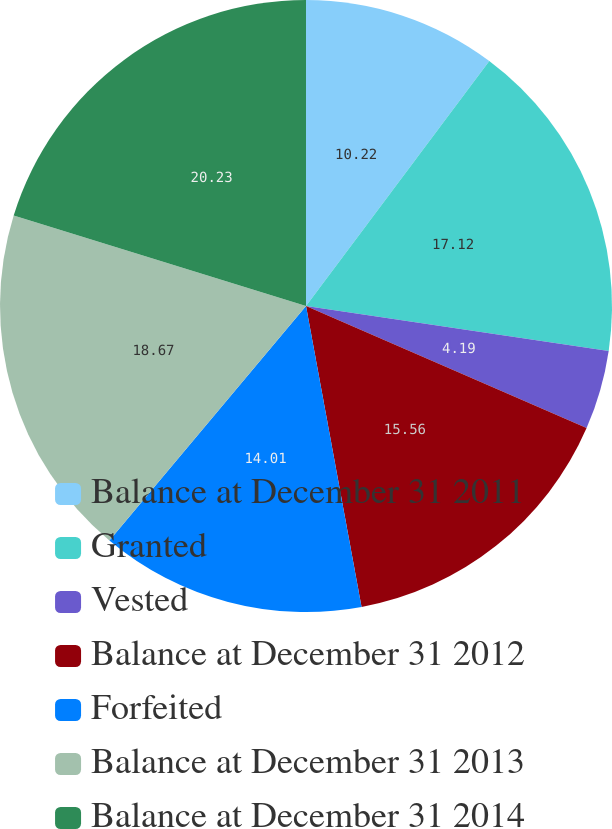<chart> <loc_0><loc_0><loc_500><loc_500><pie_chart><fcel>Balance at December 31 2011<fcel>Granted<fcel>Vested<fcel>Balance at December 31 2012<fcel>Forfeited<fcel>Balance at December 31 2013<fcel>Balance at December 31 2014<nl><fcel>10.22%<fcel>17.12%<fcel>4.19%<fcel>15.56%<fcel>14.01%<fcel>18.67%<fcel>20.22%<nl></chart> 